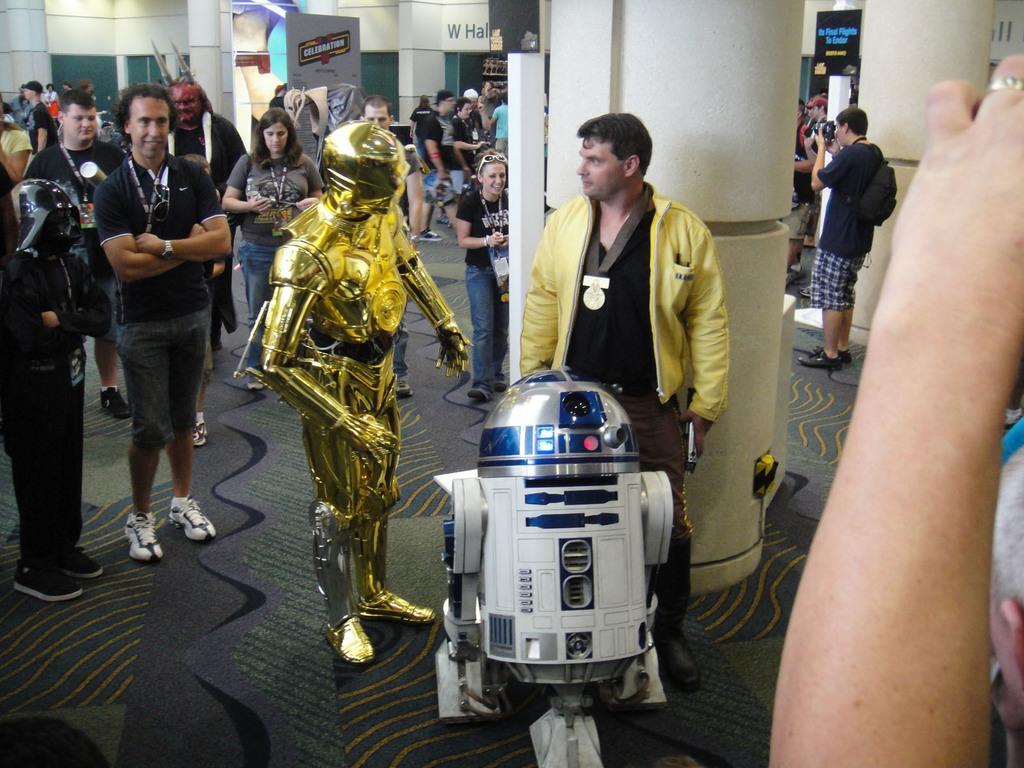In one or two sentences, can you explain what this image depicts? This image is taken indoors. At the bottom of the image there is a floor. In the background there is a wall. There are few pillars. There are many boards with text on them. In the middle of the image many people are standing on the floor and a few are walking. There is a robot and there is a device. 